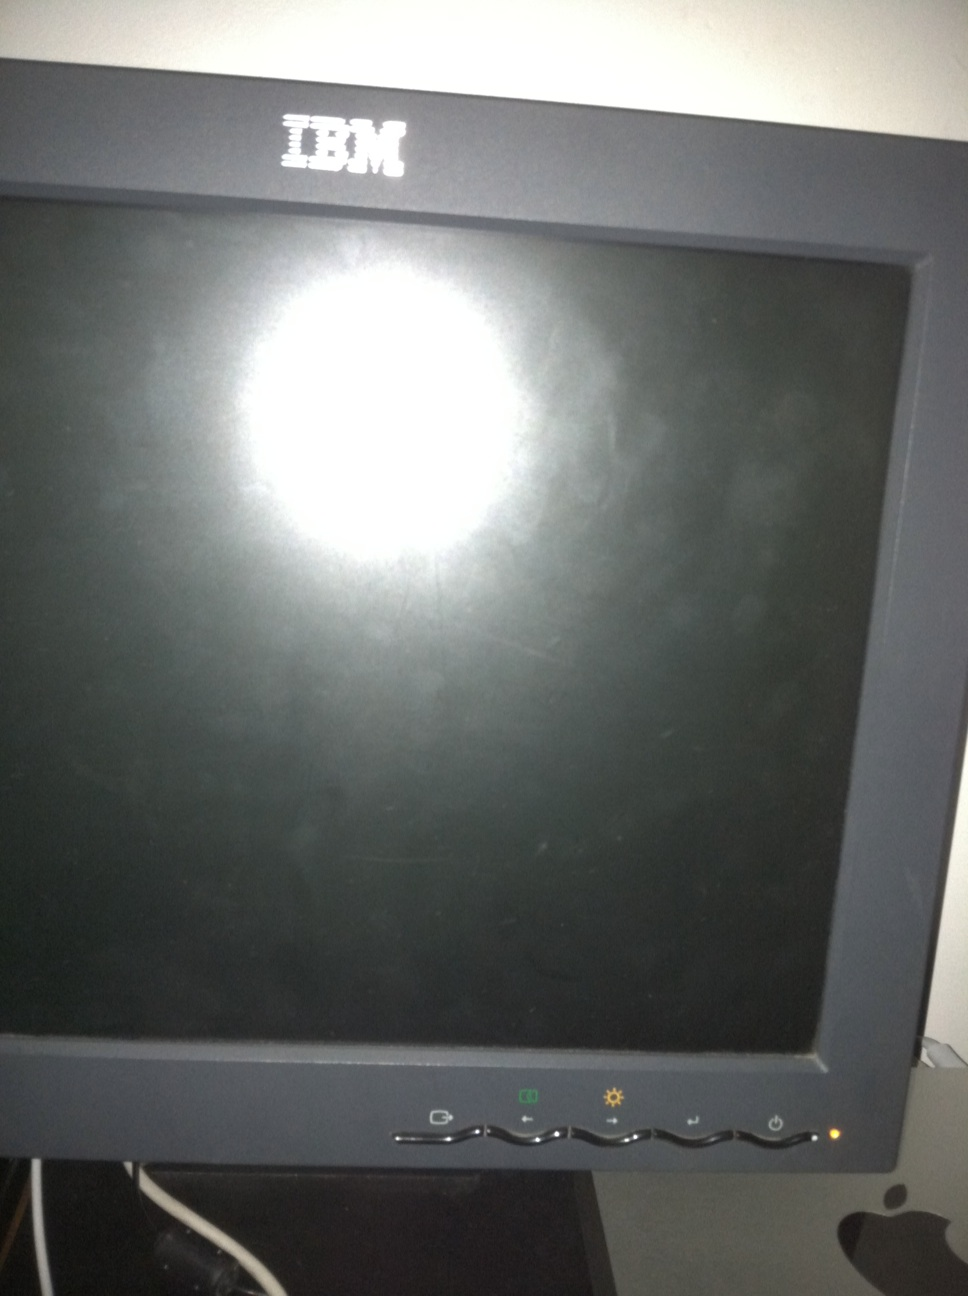Are there any visible indicators on the monitor that might suggest it is receiving power? Yes, there are a few indicators. A small green light at the bottom right of the monitor suggests that it is receiving power, even though the screen itself is off. 